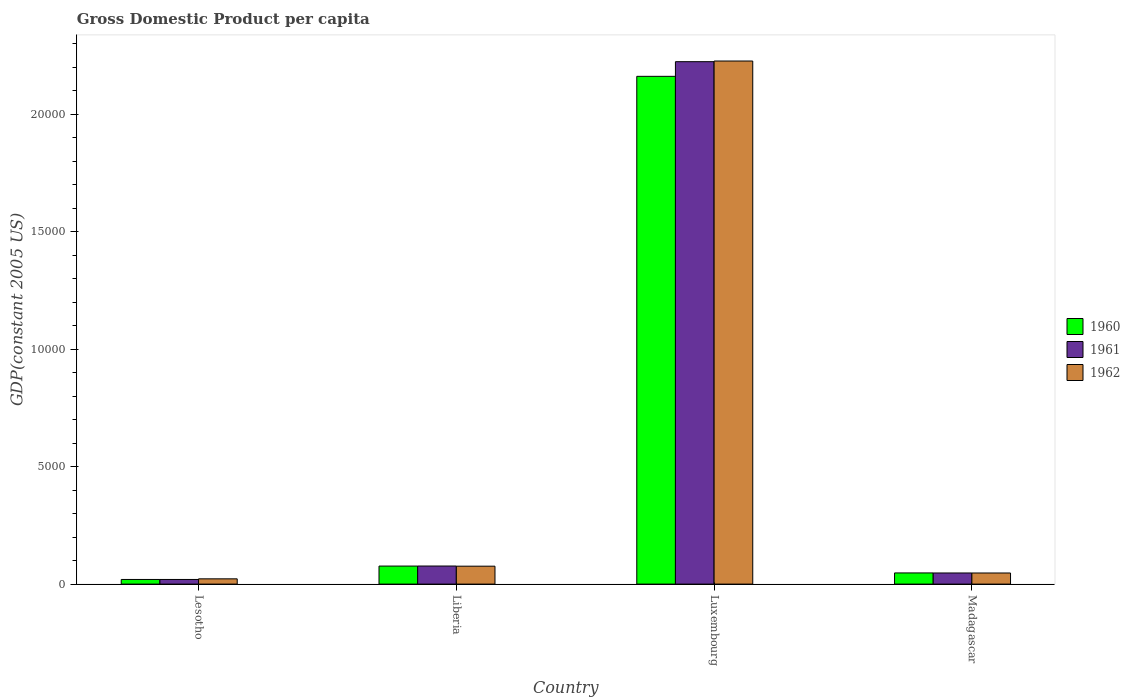How many different coloured bars are there?
Offer a terse response. 3. How many groups of bars are there?
Provide a succinct answer. 4. Are the number of bars on each tick of the X-axis equal?
Give a very brief answer. Yes. How many bars are there on the 2nd tick from the left?
Ensure brevity in your answer.  3. What is the label of the 4th group of bars from the left?
Ensure brevity in your answer.  Madagascar. What is the GDP per capita in 1961 in Luxembourg?
Make the answer very short. 2.22e+04. Across all countries, what is the maximum GDP per capita in 1961?
Ensure brevity in your answer.  2.22e+04. Across all countries, what is the minimum GDP per capita in 1961?
Your answer should be very brief. 197.61. In which country was the GDP per capita in 1962 maximum?
Your response must be concise. Luxembourg. In which country was the GDP per capita in 1960 minimum?
Give a very brief answer. Lesotho. What is the total GDP per capita in 1961 in the graph?
Ensure brevity in your answer.  2.37e+04. What is the difference between the GDP per capita in 1962 in Liberia and that in Luxembourg?
Ensure brevity in your answer.  -2.15e+04. What is the difference between the GDP per capita in 1960 in Madagascar and the GDP per capita in 1961 in Liberia?
Ensure brevity in your answer.  -293.94. What is the average GDP per capita in 1961 per country?
Give a very brief answer. 5919.63. What is the difference between the GDP per capita of/in 1962 and GDP per capita of/in 1960 in Liberia?
Offer a terse response. -4.71. What is the ratio of the GDP per capita in 1961 in Liberia to that in Madagascar?
Provide a succinct answer. 1.62. Is the GDP per capita in 1960 in Lesotho less than that in Luxembourg?
Keep it short and to the point. Yes. Is the difference between the GDP per capita in 1962 in Luxembourg and Madagascar greater than the difference between the GDP per capita in 1960 in Luxembourg and Madagascar?
Keep it short and to the point. Yes. What is the difference between the highest and the second highest GDP per capita in 1962?
Your response must be concise. -2.18e+04. What is the difference between the highest and the lowest GDP per capita in 1961?
Give a very brief answer. 2.20e+04. In how many countries, is the GDP per capita in 1960 greater than the average GDP per capita in 1960 taken over all countries?
Your answer should be very brief. 1. What does the 1st bar from the left in Liberia represents?
Offer a very short reply. 1960. What does the 1st bar from the right in Madagascar represents?
Provide a short and direct response. 1962. Is it the case that in every country, the sum of the GDP per capita in 1960 and GDP per capita in 1962 is greater than the GDP per capita in 1961?
Keep it short and to the point. Yes. What is the difference between two consecutive major ticks on the Y-axis?
Provide a succinct answer. 5000. Are the values on the major ticks of Y-axis written in scientific E-notation?
Your answer should be very brief. No. What is the title of the graph?
Keep it short and to the point. Gross Domestic Product per capita. Does "2009" appear as one of the legend labels in the graph?
Ensure brevity in your answer.  No. What is the label or title of the X-axis?
Your answer should be compact. Country. What is the label or title of the Y-axis?
Offer a very short reply. GDP(constant 2005 US). What is the GDP(constant 2005 US) in 1960 in Lesotho?
Your response must be concise. 197.38. What is the GDP(constant 2005 US) of 1961 in Lesotho?
Ensure brevity in your answer.  197.61. What is the GDP(constant 2005 US) of 1962 in Lesotho?
Provide a short and direct response. 223.86. What is the GDP(constant 2005 US) in 1960 in Liberia?
Your response must be concise. 767.6. What is the GDP(constant 2005 US) of 1961 in Liberia?
Provide a succinct answer. 769.44. What is the GDP(constant 2005 US) in 1962 in Liberia?
Keep it short and to the point. 762.88. What is the GDP(constant 2005 US) of 1960 in Luxembourg?
Your response must be concise. 2.16e+04. What is the GDP(constant 2005 US) of 1961 in Luxembourg?
Make the answer very short. 2.22e+04. What is the GDP(constant 2005 US) in 1962 in Luxembourg?
Your answer should be compact. 2.23e+04. What is the GDP(constant 2005 US) of 1960 in Madagascar?
Your answer should be compact. 475.5. What is the GDP(constant 2005 US) of 1961 in Madagascar?
Give a very brief answer. 473.7. What is the GDP(constant 2005 US) in 1962 in Madagascar?
Give a very brief answer. 472.78. Across all countries, what is the maximum GDP(constant 2005 US) of 1960?
Give a very brief answer. 2.16e+04. Across all countries, what is the maximum GDP(constant 2005 US) of 1961?
Your response must be concise. 2.22e+04. Across all countries, what is the maximum GDP(constant 2005 US) in 1962?
Provide a succinct answer. 2.23e+04. Across all countries, what is the minimum GDP(constant 2005 US) of 1960?
Provide a succinct answer. 197.38. Across all countries, what is the minimum GDP(constant 2005 US) of 1961?
Your answer should be compact. 197.61. Across all countries, what is the minimum GDP(constant 2005 US) in 1962?
Provide a short and direct response. 223.86. What is the total GDP(constant 2005 US) of 1960 in the graph?
Your answer should be compact. 2.31e+04. What is the total GDP(constant 2005 US) in 1961 in the graph?
Your response must be concise. 2.37e+04. What is the total GDP(constant 2005 US) in 1962 in the graph?
Provide a short and direct response. 2.37e+04. What is the difference between the GDP(constant 2005 US) of 1960 in Lesotho and that in Liberia?
Provide a short and direct response. -570.22. What is the difference between the GDP(constant 2005 US) in 1961 in Lesotho and that in Liberia?
Provide a succinct answer. -571.83. What is the difference between the GDP(constant 2005 US) of 1962 in Lesotho and that in Liberia?
Make the answer very short. -539.02. What is the difference between the GDP(constant 2005 US) of 1960 in Lesotho and that in Luxembourg?
Your answer should be very brief. -2.14e+04. What is the difference between the GDP(constant 2005 US) of 1961 in Lesotho and that in Luxembourg?
Keep it short and to the point. -2.20e+04. What is the difference between the GDP(constant 2005 US) of 1962 in Lesotho and that in Luxembourg?
Your answer should be very brief. -2.20e+04. What is the difference between the GDP(constant 2005 US) in 1960 in Lesotho and that in Madagascar?
Your answer should be compact. -278.12. What is the difference between the GDP(constant 2005 US) in 1961 in Lesotho and that in Madagascar?
Provide a short and direct response. -276.09. What is the difference between the GDP(constant 2005 US) of 1962 in Lesotho and that in Madagascar?
Your response must be concise. -248.91. What is the difference between the GDP(constant 2005 US) in 1960 in Liberia and that in Luxembourg?
Your response must be concise. -2.08e+04. What is the difference between the GDP(constant 2005 US) in 1961 in Liberia and that in Luxembourg?
Make the answer very short. -2.15e+04. What is the difference between the GDP(constant 2005 US) in 1962 in Liberia and that in Luxembourg?
Offer a very short reply. -2.15e+04. What is the difference between the GDP(constant 2005 US) of 1960 in Liberia and that in Madagascar?
Ensure brevity in your answer.  292.1. What is the difference between the GDP(constant 2005 US) in 1961 in Liberia and that in Madagascar?
Ensure brevity in your answer.  295.74. What is the difference between the GDP(constant 2005 US) in 1962 in Liberia and that in Madagascar?
Make the answer very short. 290.11. What is the difference between the GDP(constant 2005 US) of 1960 in Luxembourg and that in Madagascar?
Your answer should be compact. 2.11e+04. What is the difference between the GDP(constant 2005 US) of 1961 in Luxembourg and that in Madagascar?
Keep it short and to the point. 2.18e+04. What is the difference between the GDP(constant 2005 US) of 1962 in Luxembourg and that in Madagascar?
Your response must be concise. 2.18e+04. What is the difference between the GDP(constant 2005 US) in 1960 in Lesotho and the GDP(constant 2005 US) in 1961 in Liberia?
Keep it short and to the point. -572.07. What is the difference between the GDP(constant 2005 US) of 1960 in Lesotho and the GDP(constant 2005 US) of 1962 in Liberia?
Give a very brief answer. -565.51. What is the difference between the GDP(constant 2005 US) in 1961 in Lesotho and the GDP(constant 2005 US) in 1962 in Liberia?
Offer a terse response. -565.27. What is the difference between the GDP(constant 2005 US) in 1960 in Lesotho and the GDP(constant 2005 US) in 1961 in Luxembourg?
Give a very brief answer. -2.20e+04. What is the difference between the GDP(constant 2005 US) in 1960 in Lesotho and the GDP(constant 2005 US) in 1962 in Luxembourg?
Keep it short and to the point. -2.21e+04. What is the difference between the GDP(constant 2005 US) of 1961 in Lesotho and the GDP(constant 2005 US) of 1962 in Luxembourg?
Keep it short and to the point. -2.21e+04. What is the difference between the GDP(constant 2005 US) in 1960 in Lesotho and the GDP(constant 2005 US) in 1961 in Madagascar?
Your answer should be very brief. -276.32. What is the difference between the GDP(constant 2005 US) of 1960 in Lesotho and the GDP(constant 2005 US) of 1962 in Madagascar?
Offer a terse response. -275.4. What is the difference between the GDP(constant 2005 US) of 1961 in Lesotho and the GDP(constant 2005 US) of 1962 in Madagascar?
Your response must be concise. -275.16. What is the difference between the GDP(constant 2005 US) of 1960 in Liberia and the GDP(constant 2005 US) of 1961 in Luxembourg?
Keep it short and to the point. -2.15e+04. What is the difference between the GDP(constant 2005 US) of 1960 in Liberia and the GDP(constant 2005 US) of 1962 in Luxembourg?
Your response must be concise. -2.15e+04. What is the difference between the GDP(constant 2005 US) of 1961 in Liberia and the GDP(constant 2005 US) of 1962 in Luxembourg?
Make the answer very short. -2.15e+04. What is the difference between the GDP(constant 2005 US) in 1960 in Liberia and the GDP(constant 2005 US) in 1961 in Madagascar?
Give a very brief answer. 293.9. What is the difference between the GDP(constant 2005 US) in 1960 in Liberia and the GDP(constant 2005 US) in 1962 in Madagascar?
Offer a very short reply. 294.82. What is the difference between the GDP(constant 2005 US) of 1961 in Liberia and the GDP(constant 2005 US) of 1962 in Madagascar?
Provide a short and direct response. 296.67. What is the difference between the GDP(constant 2005 US) of 1960 in Luxembourg and the GDP(constant 2005 US) of 1961 in Madagascar?
Your answer should be compact. 2.11e+04. What is the difference between the GDP(constant 2005 US) in 1960 in Luxembourg and the GDP(constant 2005 US) in 1962 in Madagascar?
Provide a short and direct response. 2.11e+04. What is the difference between the GDP(constant 2005 US) in 1961 in Luxembourg and the GDP(constant 2005 US) in 1962 in Madagascar?
Offer a very short reply. 2.18e+04. What is the average GDP(constant 2005 US) of 1960 per country?
Offer a terse response. 5763.51. What is the average GDP(constant 2005 US) of 1961 per country?
Provide a short and direct response. 5919.63. What is the average GDP(constant 2005 US) in 1962 per country?
Make the answer very short. 5931.25. What is the difference between the GDP(constant 2005 US) in 1960 and GDP(constant 2005 US) in 1961 in Lesotho?
Make the answer very short. -0.24. What is the difference between the GDP(constant 2005 US) in 1960 and GDP(constant 2005 US) in 1962 in Lesotho?
Keep it short and to the point. -26.49. What is the difference between the GDP(constant 2005 US) of 1961 and GDP(constant 2005 US) of 1962 in Lesotho?
Keep it short and to the point. -26.25. What is the difference between the GDP(constant 2005 US) of 1960 and GDP(constant 2005 US) of 1961 in Liberia?
Make the answer very short. -1.85. What is the difference between the GDP(constant 2005 US) in 1960 and GDP(constant 2005 US) in 1962 in Liberia?
Keep it short and to the point. 4.71. What is the difference between the GDP(constant 2005 US) of 1961 and GDP(constant 2005 US) of 1962 in Liberia?
Your answer should be very brief. 6.56. What is the difference between the GDP(constant 2005 US) in 1960 and GDP(constant 2005 US) in 1961 in Luxembourg?
Offer a terse response. -624.17. What is the difference between the GDP(constant 2005 US) in 1960 and GDP(constant 2005 US) in 1962 in Luxembourg?
Your answer should be very brief. -651.89. What is the difference between the GDP(constant 2005 US) of 1961 and GDP(constant 2005 US) of 1962 in Luxembourg?
Give a very brief answer. -27.73. What is the difference between the GDP(constant 2005 US) in 1960 and GDP(constant 2005 US) in 1961 in Madagascar?
Give a very brief answer. 1.8. What is the difference between the GDP(constant 2005 US) of 1960 and GDP(constant 2005 US) of 1962 in Madagascar?
Make the answer very short. 2.72. What is the difference between the GDP(constant 2005 US) of 1961 and GDP(constant 2005 US) of 1962 in Madagascar?
Give a very brief answer. 0.92. What is the ratio of the GDP(constant 2005 US) of 1960 in Lesotho to that in Liberia?
Give a very brief answer. 0.26. What is the ratio of the GDP(constant 2005 US) in 1961 in Lesotho to that in Liberia?
Provide a succinct answer. 0.26. What is the ratio of the GDP(constant 2005 US) in 1962 in Lesotho to that in Liberia?
Give a very brief answer. 0.29. What is the ratio of the GDP(constant 2005 US) in 1960 in Lesotho to that in Luxembourg?
Give a very brief answer. 0.01. What is the ratio of the GDP(constant 2005 US) in 1961 in Lesotho to that in Luxembourg?
Make the answer very short. 0.01. What is the ratio of the GDP(constant 2005 US) of 1962 in Lesotho to that in Luxembourg?
Provide a short and direct response. 0.01. What is the ratio of the GDP(constant 2005 US) of 1960 in Lesotho to that in Madagascar?
Give a very brief answer. 0.42. What is the ratio of the GDP(constant 2005 US) in 1961 in Lesotho to that in Madagascar?
Your response must be concise. 0.42. What is the ratio of the GDP(constant 2005 US) in 1962 in Lesotho to that in Madagascar?
Your response must be concise. 0.47. What is the ratio of the GDP(constant 2005 US) in 1960 in Liberia to that in Luxembourg?
Keep it short and to the point. 0.04. What is the ratio of the GDP(constant 2005 US) of 1961 in Liberia to that in Luxembourg?
Your response must be concise. 0.03. What is the ratio of the GDP(constant 2005 US) in 1962 in Liberia to that in Luxembourg?
Keep it short and to the point. 0.03. What is the ratio of the GDP(constant 2005 US) in 1960 in Liberia to that in Madagascar?
Make the answer very short. 1.61. What is the ratio of the GDP(constant 2005 US) of 1961 in Liberia to that in Madagascar?
Keep it short and to the point. 1.62. What is the ratio of the GDP(constant 2005 US) of 1962 in Liberia to that in Madagascar?
Offer a terse response. 1.61. What is the ratio of the GDP(constant 2005 US) of 1960 in Luxembourg to that in Madagascar?
Offer a very short reply. 45.45. What is the ratio of the GDP(constant 2005 US) of 1961 in Luxembourg to that in Madagascar?
Provide a short and direct response. 46.95. What is the ratio of the GDP(constant 2005 US) of 1962 in Luxembourg to that in Madagascar?
Ensure brevity in your answer.  47.1. What is the difference between the highest and the second highest GDP(constant 2005 US) of 1960?
Provide a short and direct response. 2.08e+04. What is the difference between the highest and the second highest GDP(constant 2005 US) in 1961?
Offer a very short reply. 2.15e+04. What is the difference between the highest and the second highest GDP(constant 2005 US) of 1962?
Offer a very short reply. 2.15e+04. What is the difference between the highest and the lowest GDP(constant 2005 US) of 1960?
Provide a succinct answer. 2.14e+04. What is the difference between the highest and the lowest GDP(constant 2005 US) in 1961?
Keep it short and to the point. 2.20e+04. What is the difference between the highest and the lowest GDP(constant 2005 US) in 1962?
Make the answer very short. 2.20e+04. 